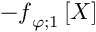<formula> <loc_0><loc_0><loc_500><loc_500>- \ m a t h s c r { f } _ { \varphi ; 1 } \left [ X \right ]</formula> 